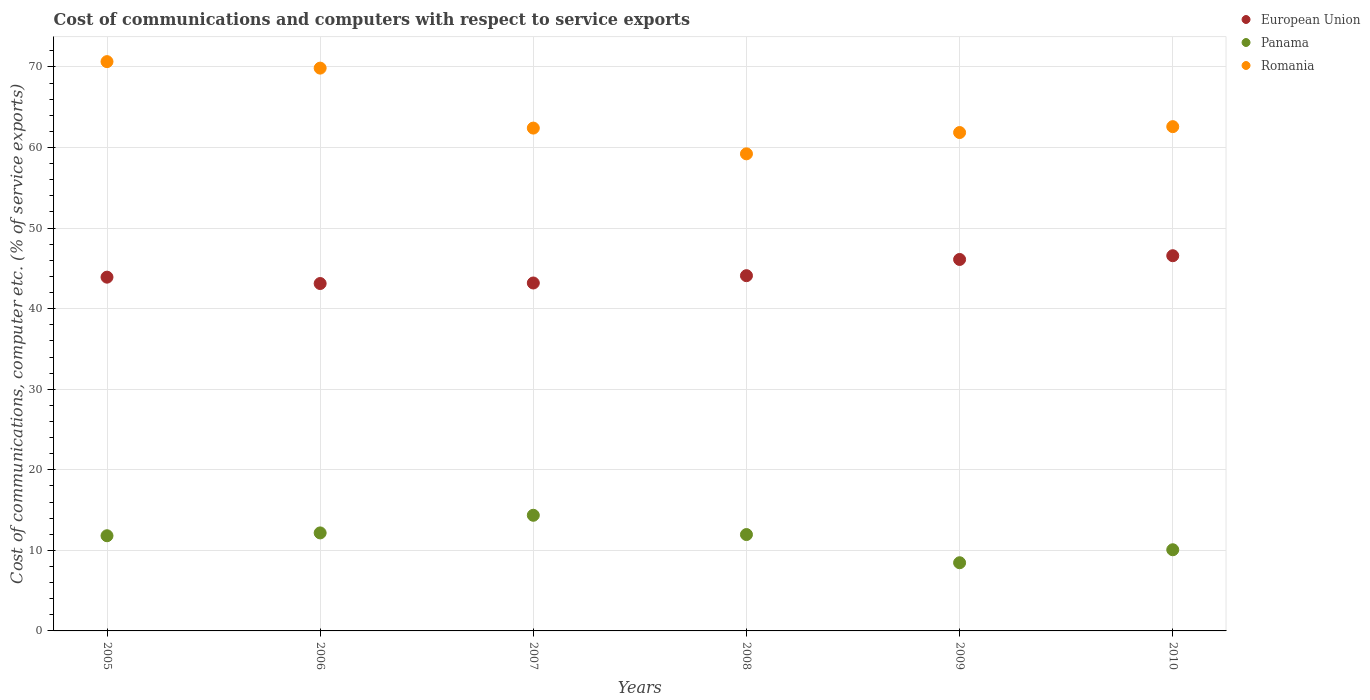Is the number of dotlines equal to the number of legend labels?
Ensure brevity in your answer.  Yes. What is the cost of communications and computers in European Union in 2009?
Give a very brief answer. 46.11. Across all years, what is the maximum cost of communications and computers in Romania?
Offer a terse response. 70.66. Across all years, what is the minimum cost of communications and computers in Romania?
Provide a short and direct response. 59.22. In which year was the cost of communications and computers in Panama maximum?
Offer a terse response. 2007. In which year was the cost of communications and computers in Panama minimum?
Ensure brevity in your answer.  2009. What is the total cost of communications and computers in European Union in the graph?
Give a very brief answer. 266.99. What is the difference between the cost of communications and computers in Panama in 2007 and that in 2009?
Your answer should be compact. 5.89. What is the difference between the cost of communications and computers in Romania in 2010 and the cost of communications and computers in European Union in 2009?
Provide a succinct answer. 16.49. What is the average cost of communications and computers in Panama per year?
Keep it short and to the point. 11.47. In the year 2008, what is the difference between the cost of communications and computers in Panama and cost of communications and computers in European Union?
Offer a very short reply. -32.13. In how many years, is the cost of communications and computers in Panama greater than 22 %?
Provide a short and direct response. 0. What is the ratio of the cost of communications and computers in Romania in 2006 to that in 2008?
Provide a short and direct response. 1.18. Is the difference between the cost of communications and computers in Panama in 2006 and 2009 greater than the difference between the cost of communications and computers in European Union in 2006 and 2009?
Provide a succinct answer. Yes. What is the difference between the highest and the second highest cost of communications and computers in Romania?
Ensure brevity in your answer.  0.81. What is the difference between the highest and the lowest cost of communications and computers in European Union?
Your response must be concise. 3.45. Is it the case that in every year, the sum of the cost of communications and computers in Panama and cost of communications and computers in European Union  is greater than the cost of communications and computers in Romania?
Provide a short and direct response. No. Does the cost of communications and computers in Panama monotonically increase over the years?
Give a very brief answer. No. Is the cost of communications and computers in European Union strictly less than the cost of communications and computers in Romania over the years?
Your answer should be very brief. Yes. How many dotlines are there?
Ensure brevity in your answer.  3. How many years are there in the graph?
Provide a short and direct response. 6. Does the graph contain any zero values?
Your answer should be compact. No. Does the graph contain grids?
Ensure brevity in your answer.  Yes. How are the legend labels stacked?
Your response must be concise. Vertical. What is the title of the graph?
Offer a very short reply. Cost of communications and computers with respect to service exports. Does "American Samoa" appear as one of the legend labels in the graph?
Offer a terse response. No. What is the label or title of the Y-axis?
Provide a short and direct response. Cost of communications, computer etc. (% of service exports). What is the Cost of communications, computer etc. (% of service exports) in European Union in 2005?
Keep it short and to the point. 43.91. What is the Cost of communications, computer etc. (% of service exports) in Panama in 2005?
Give a very brief answer. 11.81. What is the Cost of communications, computer etc. (% of service exports) in Romania in 2005?
Provide a short and direct response. 70.66. What is the Cost of communications, computer etc. (% of service exports) of European Union in 2006?
Give a very brief answer. 43.12. What is the Cost of communications, computer etc. (% of service exports) in Panama in 2006?
Your answer should be compact. 12.17. What is the Cost of communications, computer etc. (% of service exports) in Romania in 2006?
Offer a terse response. 69.86. What is the Cost of communications, computer etc. (% of service exports) of European Union in 2007?
Make the answer very short. 43.19. What is the Cost of communications, computer etc. (% of service exports) of Panama in 2007?
Offer a very short reply. 14.35. What is the Cost of communications, computer etc. (% of service exports) in Romania in 2007?
Ensure brevity in your answer.  62.41. What is the Cost of communications, computer etc. (% of service exports) in European Union in 2008?
Make the answer very short. 44.09. What is the Cost of communications, computer etc. (% of service exports) in Panama in 2008?
Ensure brevity in your answer.  11.96. What is the Cost of communications, computer etc. (% of service exports) of Romania in 2008?
Offer a very short reply. 59.22. What is the Cost of communications, computer etc. (% of service exports) in European Union in 2009?
Keep it short and to the point. 46.11. What is the Cost of communications, computer etc. (% of service exports) of Panama in 2009?
Make the answer very short. 8.46. What is the Cost of communications, computer etc. (% of service exports) of Romania in 2009?
Give a very brief answer. 61.86. What is the Cost of communications, computer etc. (% of service exports) in European Union in 2010?
Your answer should be compact. 46.57. What is the Cost of communications, computer etc. (% of service exports) of Panama in 2010?
Provide a succinct answer. 10.07. What is the Cost of communications, computer etc. (% of service exports) of Romania in 2010?
Provide a succinct answer. 62.59. Across all years, what is the maximum Cost of communications, computer etc. (% of service exports) of European Union?
Make the answer very short. 46.57. Across all years, what is the maximum Cost of communications, computer etc. (% of service exports) of Panama?
Offer a very short reply. 14.35. Across all years, what is the maximum Cost of communications, computer etc. (% of service exports) of Romania?
Your answer should be compact. 70.66. Across all years, what is the minimum Cost of communications, computer etc. (% of service exports) in European Union?
Ensure brevity in your answer.  43.12. Across all years, what is the minimum Cost of communications, computer etc. (% of service exports) of Panama?
Give a very brief answer. 8.46. Across all years, what is the minimum Cost of communications, computer etc. (% of service exports) in Romania?
Ensure brevity in your answer.  59.22. What is the total Cost of communications, computer etc. (% of service exports) of European Union in the graph?
Provide a short and direct response. 266.99. What is the total Cost of communications, computer etc. (% of service exports) of Panama in the graph?
Provide a short and direct response. 68.83. What is the total Cost of communications, computer etc. (% of service exports) of Romania in the graph?
Give a very brief answer. 386.61. What is the difference between the Cost of communications, computer etc. (% of service exports) of European Union in 2005 and that in 2006?
Offer a very short reply. 0.79. What is the difference between the Cost of communications, computer etc. (% of service exports) in Panama in 2005 and that in 2006?
Give a very brief answer. -0.35. What is the difference between the Cost of communications, computer etc. (% of service exports) in Romania in 2005 and that in 2006?
Make the answer very short. 0.81. What is the difference between the Cost of communications, computer etc. (% of service exports) of European Union in 2005 and that in 2007?
Provide a succinct answer. 0.72. What is the difference between the Cost of communications, computer etc. (% of service exports) in Panama in 2005 and that in 2007?
Make the answer very short. -2.54. What is the difference between the Cost of communications, computer etc. (% of service exports) of Romania in 2005 and that in 2007?
Offer a terse response. 8.25. What is the difference between the Cost of communications, computer etc. (% of service exports) in European Union in 2005 and that in 2008?
Your answer should be very brief. -0.18. What is the difference between the Cost of communications, computer etc. (% of service exports) of Panama in 2005 and that in 2008?
Make the answer very short. -0.15. What is the difference between the Cost of communications, computer etc. (% of service exports) in Romania in 2005 and that in 2008?
Provide a short and direct response. 11.44. What is the difference between the Cost of communications, computer etc. (% of service exports) of European Union in 2005 and that in 2009?
Give a very brief answer. -2.2. What is the difference between the Cost of communications, computer etc. (% of service exports) of Panama in 2005 and that in 2009?
Offer a terse response. 3.35. What is the difference between the Cost of communications, computer etc. (% of service exports) in Romania in 2005 and that in 2009?
Offer a very short reply. 8.8. What is the difference between the Cost of communications, computer etc. (% of service exports) of European Union in 2005 and that in 2010?
Ensure brevity in your answer.  -2.66. What is the difference between the Cost of communications, computer etc. (% of service exports) in Panama in 2005 and that in 2010?
Give a very brief answer. 1.74. What is the difference between the Cost of communications, computer etc. (% of service exports) in Romania in 2005 and that in 2010?
Provide a succinct answer. 8.07. What is the difference between the Cost of communications, computer etc. (% of service exports) of European Union in 2006 and that in 2007?
Your answer should be compact. -0.07. What is the difference between the Cost of communications, computer etc. (% of service exports) in Panama in 2006 and that in 2007?
Offer a very short reply. -2.19. What is the difference between the Cost of communications, computer etc. (% of service exports) in Romania in 2006 and that in 2007?
Your answer should be compact. 7.44. What is the difference between the Cost of communications, computer etc. (% of service exports) in European Union in 2006 and that in 2008?
Ensure brevity in your answer.  -0.97. What is the difference between the Cost of communications, computer etc. (% of service exports) of Panama in 2006 and that in 2008?
Offer a very short reply. 0.2. What is the difference between the Cost of communications, computer etc. (% of service exports) in Romania in 2006 and that in 2008?
Offer a very short reply. 10.64. What is the difference between the Cost of communications, computer etc. (% of service exports) of European Union in 2006 and that in 2009?
Ensure brevity in your answer.  -2.99. What is the difference between the Cost of communications, computer etc. (% of service exports) in Panama in 2006 and that in 2009?
Provide a succinct answer. 3.7. What is the difference between the Cost of communications, computer etc. (% of service exports) of Romania in 2006 and that in 2009?
Offer a very short reply. 7.99. What is the difference between the Cost of communications, computer etc. (% of service exports) of European Union in 2006 and that in 2010?
Make the answer very short. -3.45. What is the difference between the Cost of communications, computer etc. (% of service exports) in Panama in 2006 and that in 2010?
Provide a short and direct response. 2.09. What is the difference between the Cost of communications, computer etc. (% of service exports) in Romania in 2006 and that in 2010?
Keep it short and to the point. 7.26. What is the difference between the Cost of communications, computer etc. (% of service exports) in European Union in 2007 and that in 2008?
Ensure brevity in your answer.  -0.91. What is the difference between the Cost of communications, computer etc. (% of service exports) in Panama in 2007 and that in 2008?
Ensure brevity in your answer.  2.39. What is the difference between the Cost of communications, computer etc. (% of service exports) of Romania in 2007 and that in 2008?
Provide a short and direct response. 3.19. What is the difference between the Cost of communications, computer etc. (% of service exports) in European Union in 2007 and that in 2009?
Your answer should be compact. -2.92. What is the difference between the Cost of communications, computer etc. (% of service exports) of Panama in 2007 and that in 2009?
Your answer should be very brief. 5.89. What is the difference between the Cost of communications, computer etc. (% of service exports) in Romania in 2007 and that in 2009?
Your answer should be very brief. 0.55. What is the difference between the Cost of communications, computer etc. (% of service exports) of European Union in 2007 and that in 2010?
Make the answer very short. -3.39. What is the difference between the Cost of communications, computer etc. (% of service exports) of Panama in 2007 and that in 2010?
Your answer should be very brief. 4.28. What is the difference between the Cost of communications, computer etc. (% of service exports) of Romania in 2007 and that in 2010?
Make the answer very short. -0.18. What is the difference between the Cost of communications, computer etc. (% of service exports) in European Union in 2008 and that in 2009?
Offer a very short reply. -2.01. What is the difference between the Cost of communications, computer etc. (% of service exports) of Panama in 2008 and that in 2009?
Your answer should be compact. 3.5. What is the difference between the Cost of communications, computer etc. (% of service exports) in Romania in 2008 and that in 2009?
Make the answer very short. -2.64. What is the difference between the Cost of communications, computer etc. (% of service exports) in European Union in 2008 and that in 2010?
Make the answer very short. -2.48. What is the difference between the Cost of communications, computer etc. (% of service exports) in Panama in 2008 and that in 2010?
Make the answer very short. 1.89. What is the difference between the Cost of communications, computer etc. (% of service exports) of Romania in 2008 and that in 2010?
Ensure brevity in your answer.  -3.37. What is the difference between the Cost of communications, computer etc. (% of service exports) of European Union in 2009 and that in 2010?
Offer a terse response. -0.46. What is the difference between the Cost of communications, computer etc. (% of service exports) of Panama in 2009 and that in 2010?
Offer a very short reply. -1.61. What is the difference between the Cost of communications, computer etc. (% of service exports) of Romania in 2009 and that in 2010?
Your answer should be compact. -0.73. What is the difference between the Cost of communications, computer etc. (% of service exports) of European Union in 2005 and the Cost of communications, computer etc. (% of service exports) of Panama in 2006?
Offer a terse response. 31.75. What is the difference between the Cost of communications, computer etc. (% of service exports) of European Union in 2005 and the Cost of communications, computer etc. (% of service exports) of Romania in 2006?
Provide a short and direct response. -25.95. What is the difference between the Cost of communications, computer etc. (% of service exports) in Panama in 2005 and the Cost of communications, computer etc. (% of service exports) in Romania in 2006?
Offer a very short reply. -58.04. What is the difference between the Cost of communications, computer etc. (% of service exports) of European Union in 2005 and the Cost of communications, computer etc. (% of service exports) of Panama in 2007?
Your answer should be compact. 29.56. What is the difference between the Cost of communications, computer etc. (% of service exports) in European Union in 2005 and the Cost of communications, computer etc. (% of service exports) in Romania in 2007?
Ensure brevity in your answer.  -18.5. What is the difference between the Cost of communications, computer etc. (% of service exports) of Panama in 2005 and the Cost of communications, computer etc. (% of service exports) of Romania in 2007?
Offer a very short reply. -50.6. What is the difference between the Cost of communications, computer etc. (% of service exports) in European Union in 2005 and the Cost of communications, computer etc. (% of service exports) in Panama in 2008?
Your response must be concise. 31.95. What is the difference between the Cost of communications, computer etc. (% of service exports) of European Union in 2005 and the Cost of communications, computer etc. (% of service exports) of Romania in 2008?
Your answer should be very brief. -15.31. What is the difference between the Cost of communications, computer etc. (% of service exports) of Panama in 2005 and the Cost of communications, computer etc. (% of service exports) of Romania in 2008?
Your response must be concise. -47.41. What is the difference between the Cost of communications, computer etc. (% of service exports) in European Union in 2005 and the Cost of communications, computer etc. (% of service exports) in Panama in 2009?
Make the answer very short. 35.45. What is the difference between the Cost of communications, computer etc. (% of service exports) in European Union in 2005 and the Cost of communications, computer etc. (% of service exports) in Romania in 2009?
Your response must be concise. -17.95. What is the difference between the Cost of communications, computer etc. (% of service exports) of Panama in 2005 and the Cost of communications, computer etc. (% of service exports) of Romania in 2009?
Ensure brevity in your answer.  -50.05. What is the difference between the Cost of communications, computer etc. (% of service exports) of European Union in 2005 and the Cost of communications, computer etc. (% of service exports) of Panama in 2010?
Offer a very short reply. 33.84. What is the difference between the Cost of communications, computer etc. (% of service exports) of European Union in 2005 and the Cost of communications, computer etc. (% of service exports) of Romania in 2010?
Your response must be concise. -18.68. What is the difference between the Cost of communications, computer etc. (% of service exports) in Panama in 2005 and the Cost of communications, computer etc. (% of service exports) in Romania in 2010?
Ensure brevity in your answer.  -50.78. What is the difference between the Cost of communications, computer etc. (% of service exports) in European Union in 2006 and the Cost of communications, computer etc. (% of service exports) in Panama in 2007?
Offer a very short reply. 28.77. What is the difference between the Cost of communications, computer etc. (% of service exports) in European Union in 2006 and the Cost of communications, computer etc. (% of service exports) in Romania in 2007?
Provide a short and direct response. -19.29. What is the difference between the Cost of communications, computer etc. (% of service exports) in Panama in 2006 and the Cost of communications, computer etc. (% of service exports) in Romania in 2007?
Ensure brevity in your answer.  -50.25. What is the difference between the Cost of communications, computer etc. (% of service exports) of European Union in 2006 and the Cost of communications, computer etc. (% of service exports) of Panama in 2008?
Keep it short and to the point. 31.16. What is the difference between the Cost of communications, computer etc. (% of service exports) of European Union in 2006 and the Cost of communications, computer etc. (% of service exports) of Romania in 2008?
Give a very brief answer. -16.1. What is the difference between the Cost of communications, computer etc. (% of service exports) in Panama in 2006 and the Cost of communications, computer etc. (% of service exports) in Romania in 2008?
Your answer should be compact. -47.05. What is the difference between the Cost of communications, computer etc. (% of service exports) in European Union in 2006 and the Cost of communications, computer etc. (% of service exports) in Panama in 2009?
Provide a succinct answer. 34.66. What is the difference between the Cost of communications, computer etc. (% of service exports) of European Union in 2006 and the Cost of communications, computer etc. (% of service exports) of Romania in 2009?
Ensure brevity in your answer.  -18.74. What is the difference between the Cost of communications, computer etc. (% of service exports) of Panama in 2006 and the Cost of communications, computer etc. (% of service exports) of Romania in 2009?
Give a very brief answer. -49.7. What is the difference between the Cost of communications, computer etc. (% of service exports) in European Union in 2006 and the Cost of communications, computer etc. (% of service exports) in Panama in 2010?
Keep it short and to the point. 33.05. What is the difference between the Cost of communications, computer etc. (% of service exports) in European Union in 2006 and the Cost of communications, computer etc. (% of service exports) in Romania in 2010?
Offer a terse response. -19.47. What is the difference between the Cost of communications, computer etc. (% of service exports) of Panama in 2006 and the Cost of communications, computer etc. (% of service exports) of Romania in 2010?
Provide a short and direct response. -50.43. What is the difference between the Cost of communications, computer etc. (% of service exports) of European Union in 2007 and the Cost of communications, computer etc. (% of service exports) of Panama in 2008?
Your response must be concise. 31.22. What is the difference between the Cost of communications, computer etc. (% of service exports) of European Union in 2007 and the Cost of communications, computer etc. (% of service exports) of Romania in 2008?
Your answer should be very brief. -16.03. What is the difference between the Cost of communications, computer etc. (% of service exports) in Panama in 2007 and the Cost of communications, computer etc. (% of service exports) in Romania in 2008?
Make the answer very short. -44.86. What is the difference between the Cost of communications, computer etc. (% of service exports) in European Union in 2007 and the Cost of communications, computer etc. (% of service exports) in Panama in 2009?
Give a very brief answer. 34.72. What is the difference between the Cost of communications, computer etc. (% of service exports) of European Union in 2007 and the Cost of communications, computer etc. (% of service exports) of Romania in 2009?
Offer a terse response. -18.68. What is the difference between the Cost of communications, computer etc. (% of service exports) in Panama in 2007 and the Cost of communications, computer etc. (% of service exports) in Romania in 2009?
Ensure brevity in your answer.  -47.51. What is the difference between the Cost of communications, computer etc. (% of service exports) in European Union in 2007 and the Cost of communications, computer etc. (% of service exports) in Panama in 2010?
Your response must be concise. 33.11. What is the difference between the Cost of communications, computer etc. (% of service exports) of European Union in 2007 and the Cost of communications, computer etc. (% of service exports) of Romania in 2010?
Provide a short and direct response. -19.41. What is the difference between the Cost of communications, computer etc. (% of service exports) in Panama in 2007 and the Cost of communications, computer etc. (% of service exports) in Romania in 2010?
Your answer should be compact. -48.24. What is the difference between the Cost of communications, computer etc. (% of service exports) in European Union in 2008 and the Cost of communications, computer etc. (% of service exports) in Panama in 2009?
Your answer should be very brief. 35.63. What is the difference between the Cost of communications, computer etc. (% of service exports) in European Union in 2008 and the Cost of communications, computer etc. (% of service exports) in Romania in 2009?
Provide a succinct answer. -17.77. What is the difference between the Cost of communications, computer etc. (% of service exports) in Panama in 2008 and the Cost of communications, computer etc. (% of service exports) in Romania in 2009?
Offer a terse response. -49.9. What is the difference between the Cost of communications, computer etc. (% of service exports) in European Union in 2008 and the Cost of communications, computer etc. (% of service exports) in Panama in 2010?
Provide a succinct answer. 34.02. What is the difference between the Cost of communications, computer etc. (% of service exports) in European Union in 2008 and the Cost of communications, computer etc. (% of service exports) in Romania in 2010?
Keep it short and to the point. -18.5. What is the difference between the Cost of communications, computer etc. (% of service exports) of Panama in 2008 and the Cost of communications, computer etc. (% of service exports) of Romania in 2010?
Ensure brevity in your answer.  -50.63. What is the difference between the Cost of communications, computer etc. (% of service exports) of European Union in 2009 and the Cost of communications, computer etc. (% of service exports) of Panama in 2010?
Ensure brevity in your answer.  36.03. What is the difference between the Cost of communications, computer etc. (% of service exports) in European Union in 2009 and the Cost of communications, computer etc. (% of service exports) in Romania in 2010?
Ensure brevity in your answer.  -16.49. What is the difference between the Cost of communications, computer etc. (% of service exports) in Panama in 2009 and the Cost of communications, computer etc. (% of service exports) in Romania in 2010?
Offer a very short reply. -54.13. What is the average Cost of communications, computer etc. (% of service exports) of European Union per year?
Your response must be concise. 44.5. What is the average Cost of communications, computer etc. (% of service exports) of Panama per year?
Your response must be concise. 11.47. What is the average Cost of communications, computer etc. (% of service exports) of Romania per year?
Your answer should be very brief. 64.44. In the year 2005, what is the difference between the Cost of communications, computer etc. (% of service exports) of European Union and Cost of communications, computer etc. (% of service exports) of Panama?
Your answer should be compact. 32.1. In the year 2005, what is the difference between the Cost of communications, computer etc. (% of service exports) in European Union and Cost of communications, computer etc. (% of service exports) in Romania?
Provide a short and direct response. -26.75. In the year 2005, what is the difference between the Cost of communications, computer etc. (% of service exports) of Panama and Cost of communications, computer etc. (% of service exports) of Romania?
Ensure brevity in your answer.  -58.85. In the year 2006, what is the difference between the Cost of communications, computer etc. (% of service exports) of European Union and Cost of communications, computer etc. (% of service exports) of Panama?
Provide a short and direct response. 30.96. In the year 2006, what is the difference between the Cost of communications, computer etc. (% of service exports) of European Union and Cost of communications, computer etc. (% of service exports) of Romania?
Make the answer very short. -26.74. In the year 2006, what is the difference between the Cost of communications, computer etc. (% of service exports) in Panama and Cost of communications, computer etc. (% of service exports) in Romania?
Provide a short and direct response. -57.69. In the year 2007, what is the difference between the Cost of communications, computer etc. (% of service exports) in European Union and Cost of communications, computer etc. (% of service exports) in Panama?
Provide a succinct answer. 28.83. In the year 2007, what is the difference between the Cost of communications, computer etc. (% of service exports) in European Union and Cost of communications, computer etc. (% of service exports) in Romania?
Ensure brevity in your answer.  -19.23. In the year 2007, what is the difference between the Cost of communications, computer etc. (% of service exports) of Panama and Cost of communications, computer etc. (% of service exports) of Romania?
Make the answer very short. -48.06. In the year 2008, what is the difference between the Cost of communications, computer etc. (% of service exports) of European Union and Cost of communications, computer etc. (% of service exports) of Panama?
Your answer should be very brief. 32.13. In the year 2008, what is the difference between the Cost of communications, computer etc. (% of service exports) in European Union and Cost of communications, computer etc. (% of service exports) in Romania?
Provide a short and direct response. -15.13. In the year 2008, what is the difference between the Cost of communications, computer etc. (% of service exports) in Panama and Cost of communications, computer etc. (% of service exports) in Romania?
Your answer should be compact. -47.26. In the year 2009, what is the difference between the Cost of communications, computer etc. (% of service exports) in European Union and Cost of communications, computer etc. (% of service exports) in Panama?
Your response must be concise. 37.65. In the year 2009, what is the difference between the Cost of communications, computer etc. (% of service exports) in European Union and Cost of communications, computer etc. (% of service exports) in Romania?
Ensure brevity in your answer.  -15.75. In the year 2009, what is the difference between the Cost of communications, computer etc. (% of service exports) of Panama and Cost of communications, computer etc. (% of service exports) of Romania?
Give a very brief answer. -53.4. In the year 2010, what is the difference between the Cost of communications, computer etc. (% of service exports) in European Union and Cost of communications, computer etc. (% of service exports) in Panama?
Make the answer very short. 36.5. In the year 2010, what is the difference between the Cost of communications, computer etc. (% of service exports) in European Union and Cost of communications, computer etc. (% of service exports) in Romania?
Make the answer very short. -16.02. In the year 2010, what is the difference between the Cost of communications, computer etc. (% of service exports) in Panama and Cost of communications, computer etc. (% of service exports) in Romania?
Your response must be concise. -52.52. What is the ratio of the Cost of communications, computer etc. (% of service exports) of European Union in 2005 to that in 2006?
Give a very brief answer. 1.02. What is the ratio of the Cost of communications, computer etc. (% of service exports) in Panama in 2005 to that in 2006?
Provide a short and direct response. 0.97. What is the ratio of the Cost of communications, computer etc. (% of service exports) of Romania in 2005 to that in 2006?
Your answer should be compact. 1.01. What is the ratio of the Cost of communications, computer etc. (% of service exports) of European Union in 2005 to that in 2007?
Make the answer very short. 1.02. What is the ratio of the Cost of communications, computer etc. (% of service exports) of Panama in 2005 to that in 2007?
Offer a terse response. 0.82. What is the ratio of the Cost of communications, computer etc. (% of service exports) of Romania in 2005 to that in 2007?
Make the answer very short. 1.13. What is the ratio of the Cost of communications, computer etc. (% of service exports) of European Union in 2005 to that in 2008?
Provide a short and direct response. 1. What is the ratio of the Cost of communications, computer etc. (% of service exports) in Panama in 2005 to that in 2008?
Your answer should be very brief. 0.99. What is the ratio of the Cost of communications, computer etc. (% of service exports) in Romania in 2005 to that in 2008?
Offer a terse response. 1.19. What is the ratio of the Cost of communications, computer etc. (% of service exports) of Panama in 2005 to that in 2009?
Offer a very short reply. 1.4. What is the ratio of the Cost of communications, computer etc. (% of service exports) in Romania in 2005 to that in 2009?
Your answer should be compact. 1.14. What is the ratio of the Cost of communications, computer etc. (% of service exports) of European Union in 2005 to that in 2010?
Make the answer very short. 0.94. What is the ratio of the Cost of communications, computer etc. (% of service exports) of Panama in 2005 to that in 2010?
Your answer should be compact. 1.17. What is the ratio of the Cost of communications, computer etc. (% of service exports) in Romania in 2005 to that in 2010?
Provide a succinct answer. 1.13. What is the ratio of the Cost of communications, computer etc. (% of service exports) in Panama in 2006 to that in 2007?
Give a very brief answer. 0.85. What is the ratio of the Cost of communications, computer etc. (% of service exports) of Romania in 2006 to that in 2007?
Provide a short and direct response. 1.12. What is the ratio of the Cost of communications, computer etc. (% of service exports) of European Union in 2006 to that in 2008?
Your answer should be compact. 0.98. What is the ratio of the Cost of communications, computer etc. (% of service exports) in Panama in 2006 to that in 2008?
Your answer should be very brief. 1.02. What is the ratio of the Cost of communications, computer etc. (% of service exports) of Romania in 2006 to that in 2008?
Provide a succinct answer. 1.18. What is the ratio of the Cost of communications, computer etc. (% of service exports) of European Union in 2006 to that in 2009?
Give a very brief answer. 0.94. What is the ratio of the Cost of communications, computer etc. (% of service exports) of Panama in 2006 to that in 2009?
Your response must be concise. 1.44. What is the ratio of the Cost of communications, computer etc. (% of service exports) of Romania in 2006 to that in 2009?
Your answer should be very brief. 1.13. What is the ratio of the Cost of communications, computer etc. (% of service exports) in European Union in 2006 to that in 2010?
Offer a terse response. 0.93. What is the ratio of the Cost of communications, computer etc. (% of service exports) in Panama in 2006 to that in 2010?
Give a very brief answer. 1.21. What is the ratio of the Cost of communications, computer etc. (% of service exports) in Romania in 2006 to that in 2010?
Give a very brief answer. 1.12. What is the ratio of the Cost of communications, computer etc. (% of service exports) in European Union in 2007 to that in 2008?
Your answer should be very brief. 0.98. What is the ratio of the Cost of communications, computer etc. (% of service exports) in Romania in 2007 to that in 2008?
Provide a succinct answer. 1.05. What is the ratio of the Cost of communications, computer etc. (% of service exports) of European Union in 2007 to that in 2009?
Provide a short and direct response. 0.94. What is the ratio of the Cost of communications, computer etc. (% of service exports) in Panama in 2007 to that in 2009?
Offer a terse response. 1.7. What is the ratio of the Cost of communications, computer etc. (% of service exports) in Romania in 2007 to that in 2009?
Your response must be concise. 1.01. What is the ratio of the Cost of communications, computer etc. (% of service exports) of European Union in 2007 to that in 2010?
Ensure brevity in your answer.  0.93. What is the ratio of the Cost of communications, computer etc. (% of service exports) in Panama in 2007 to that in 2010?
Give a very brief answer. 1.42. What is the ratio of the Cost of communications, computer etc. (% of service exports) in European Union in 2008 to that in 2009?
Keep it short and to the point. 0.96. What is the ratio of the Cost of communications, computer etc. (% of service exports) of Panama in 2008 to that in 2009?
Provide a succinct answer. 1.41. What is the ratio of the Cost of communications, computer etc. (% of service exports) of Romania in 2008 to that in 2009?
Offer a very short reply. 0.96. What is the ratio of the Cost of communications, computer etc. (% of service exports) of European Union in 2008 to that in 2010?
Give a very brief answer. 0.95. What is the ratio of the Cost of communications, computer etc. (% of service exports) in Panama in 2008 to that in 2010?
Keep it short and to the point. 1.19. What is the ratio of the Cost of communications, computer etc. (% of service exports) of Romania in 2008 to that in 2010?
Keep it short and to the point. 0.95. What is the ratio of the Cost of communications, computer etc. (% of service exports) of European Union in 2009 to that in 2010?
Your response must be concise. 0.99. What is the ratio of the Cost of communications, computer etc. (% of service exports) of Panama in 2009 to that in 2010?
Ensure brevity in your answer.  0.84. What is the ratio of the Cost of communications, computer etc. (% of service exports) of Romania in 2009 to that in 2010?
Keep it short and to the point. 0.99. What is the difference between the highest and the second highest Cost of communications, computer etc. (% of service exports) of European Union?
Provide a short and direct response. 0.46. What is the difference between the highest and the second highest Cost of communications, computer etc. (% of service exports) of Panama?
Offer a very short reply. 2.19. What is the difference between the highest and the second highest Cost of communications, computer etc. (% of service exports) in Romania?
Provide a short and direct response. 0.81. What is the difference between the highest and the lowest Cost of communications, computer etc. (% of service exports) of European Union?
Provide a short and direct response. 3.45. What is the difference between the highest and the lowest Cost of communications, computer etc. (% of service exports) of Panama?
Make the answer very short. 5.89. What is the difference between the highest and the lowest Cost of communications, computer etc. (% of service exports) in Romania?
Provide a succinct answer. 11.44. 